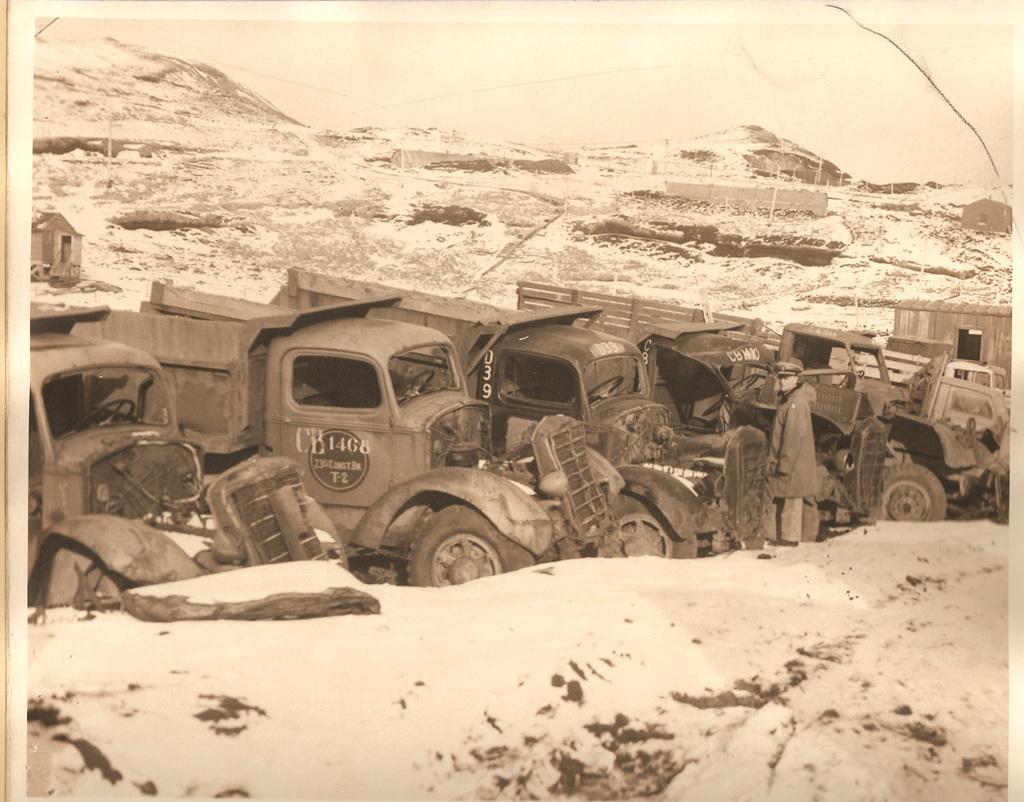Please provide a concise description of this image. In this picture we can see some text and numbers on the vehicles. We can see a person standing. He is wearing a hat and the mask on his face. We can see the hills, snow and the sky. 